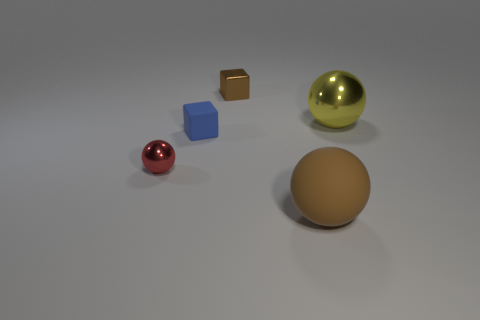Subtract all large balls. How many balls are left? 1 Add 3 tiny blocks. How many objects exist? 8 Subtract all cubes. How many objects are left? 3 Subtract all large brown metallic things. Subtract all brown things. How many objects are left? 3 Add 2 yellow metal balls. How many yellow metal balls are left? 3 Add 4 cyan rubber objects. How many cyan rubber objects exist? 4 Subtract 0 red cylinders. How many objects are left? 5 